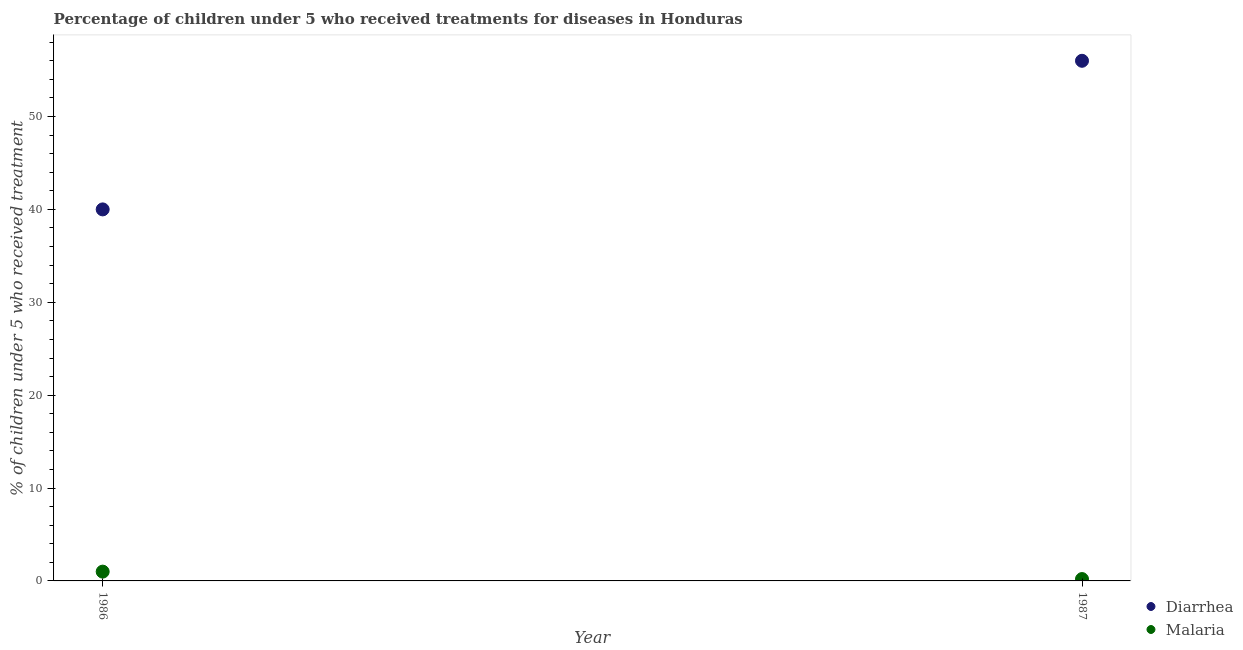What is the percentage of children who received treatment for malaria in 1987?
Keep it short and to the point. 0.2. Across all years, what is the maximum percentage of children who received treatment for malaria?
Make the answer very short. 1. Across all years, what is the minimum percentage of children who received treatment for malaria?
Provide a short and direct response. 0.2. In which year was the percentage of children who received treatment for diarrhoea maximum?
Offer a terse response. 1987. In which year was the percentage of children who received treatment for diarrhoea minimum?
Provide a succinct answer. 1986. What is the total percentage of children who received treatment for diarrhoea in the graph?
Provide a short and direct response. 96. What is the difference between the percentage of children who received treatment for diarrhoea in 1986 and that in 1987?
Keep it short and to the point. -16. What is the difference between the percentage of children who received treatment for malaria in 1987 and the percentage of children who received treatment for diarrhoea in 1986?
Your response must be concise. -39.8. In the year 1986, what is the difference between the percentage of children who received treatment for diarrhoea and percentage of children who received treatment for malaria?
Ensure brevity in your answer.  39. Is the percentage of children who received treatment for diarrhoea in 1986 less than that in 1987?
Provide a short and direct response. Yes. How many dotlines are there?
Keep it short and to the point. 2. How many years are there in the graph?
Make the answer very short. 2. Does the graph contain any zero values?
Your answer should be compact. No. Where does the legend appear in the graph?
Ensure brevity in your answer.  Bottom right. How many legend labels are there?
Your answer should be compact. 2. How are the legend labels stacked?
Offer a terse response. Vertical. What is the title of the graph?
Give a very brief answer. Percentage of children under 5 who received treatments for diseases in Honduras. What is the label or title of the Y-axis?
Offer a terse response. % of children under 5 who received treatment. What is the % of children under 5 who received treatment in Malaria in 1986?
Provide a succinct answer. 1. What is the % of children under 5 who received treatment of Diarrhea in 1987?
Ensure brevity in your answer.  56. What is the % of children under 5 who received treatment of Malaria in 1987?
Your response must be concise. 0.2. Across all years, what is the minimum % of children under 5 who received treatment of Malaria?
Keep it short and to the point. 0.2. What is the total % of children under 5 who received treatment of Diarrhea in the graph?
Give a very brief answer. 96. What is the difference between the % of children under 5 who received treatment of Diarrhea in 1986 and that in 1987?
Your answer should be compact. -16. What is the difference between the % of children under 5 who received treatment in Diarrhea in 1986 and the % of children under 5 who received treatment in Malaria in 1987?
Ensure brevity in your answer.  39.8. What is the average % of children under 5 who received treatment of Diarrhea per year?
Make the answer very short. 48. What is the average % of children under 5 who received treatment in Malaria per year?
Ensure brevity in your answer.  0.6. In the year 1986, what is the difference between the % of children under 5 who received treatment of Diarrhea and % of children under 5 who received treatment of Malaria?
Provide a succinct answer. 39. In the year 1987, what is the difference between the % of children under 5 who received treatment of Diarrhea and % of children under 5 who received treatment of Malaria?
Ensure brevity in your answer.  55.8. What is the ratio of the % of children under 5 who received treatment of Malaria in 1986 to that in 1987?
Give a very brief answer. 5. What is the difference between the highest and the second highest % of children under 5 who received treatment in Diarrhea?
Provide a succinct answer. 16. What is the difference between the highest and the lowest % of children under 5 who received treatment of Diarrhea?
Offer a very short reply. 16. What is the difference between the highest and the lowest % of children under 5 who received treatment of Malaria?
Your response must be concise. 0.8. 